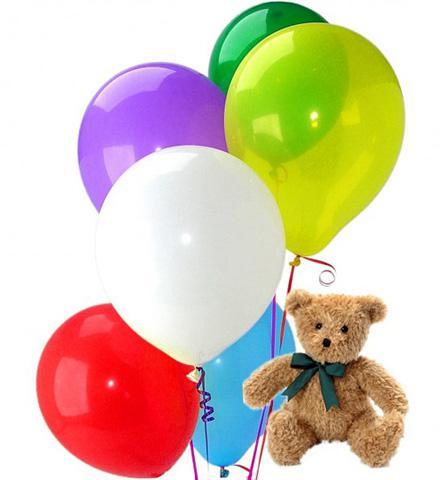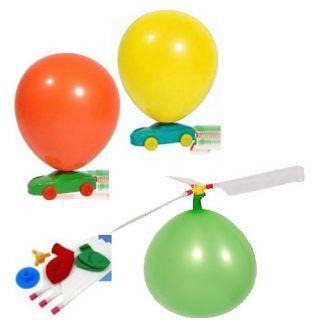The first image is the image on the left, the second image is the image on the right. Considering the images on both sides, is "The right image has three balloons all facing upwards." valid? Answer yes or no. No. 